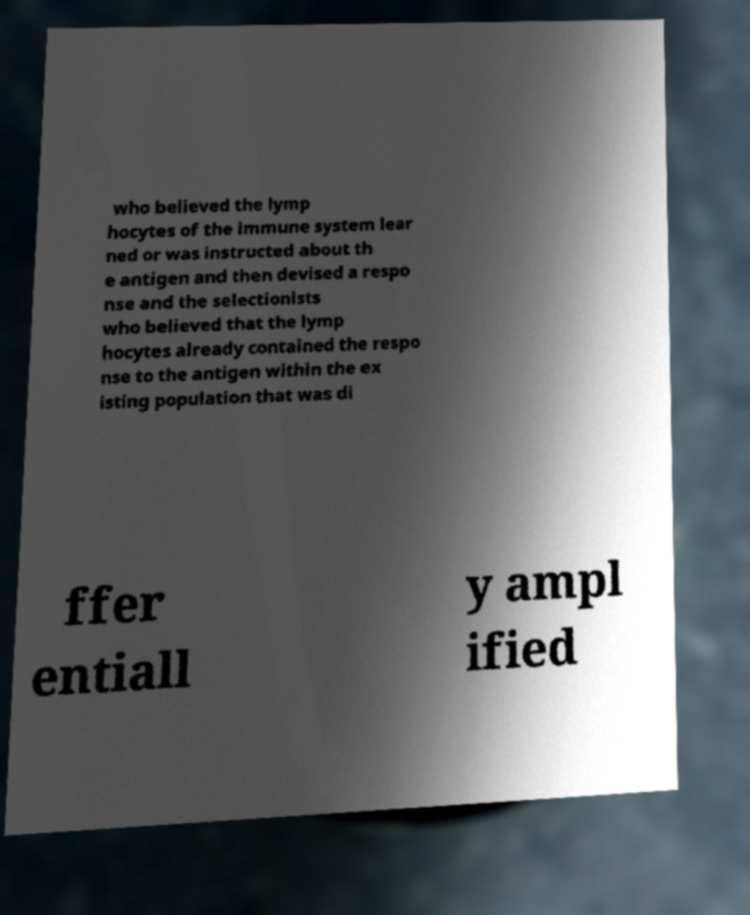Could you assist in decoding the text presented in this image and type it out clearly? who believed the lymp hocytes of the immune system lear ned or was instructed about th e antigen and then devised a respo nse and the selectionists who believed that the lymp hocytes already contained the respo nse to the antigen within the ex isting population that was di ffer entiall y ampl ified 